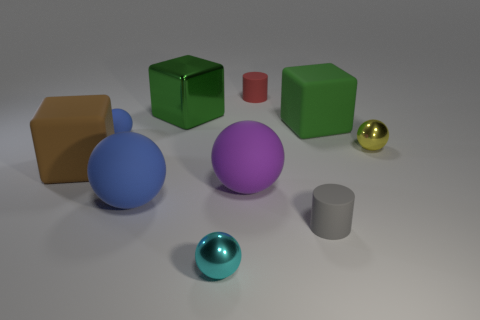Subtract 2 balls. How many balls are left? 3 Subtract all red balls. Subtract all purple cylinders. How many balls are left? 5 Subtract all blocks. How many objects are left? 7 Add 3 large yellow metal blocks. How many large yellow metal blocks exist? 3 Subtract 0 cyan cubes. How many objects are left? 10 Subtract all tiny gray blocks. Subtract all small gray rubber things. How many objects are left? 9 Add 9 tiny gray rubber things. How many tiny gray rubber things are left? 10 